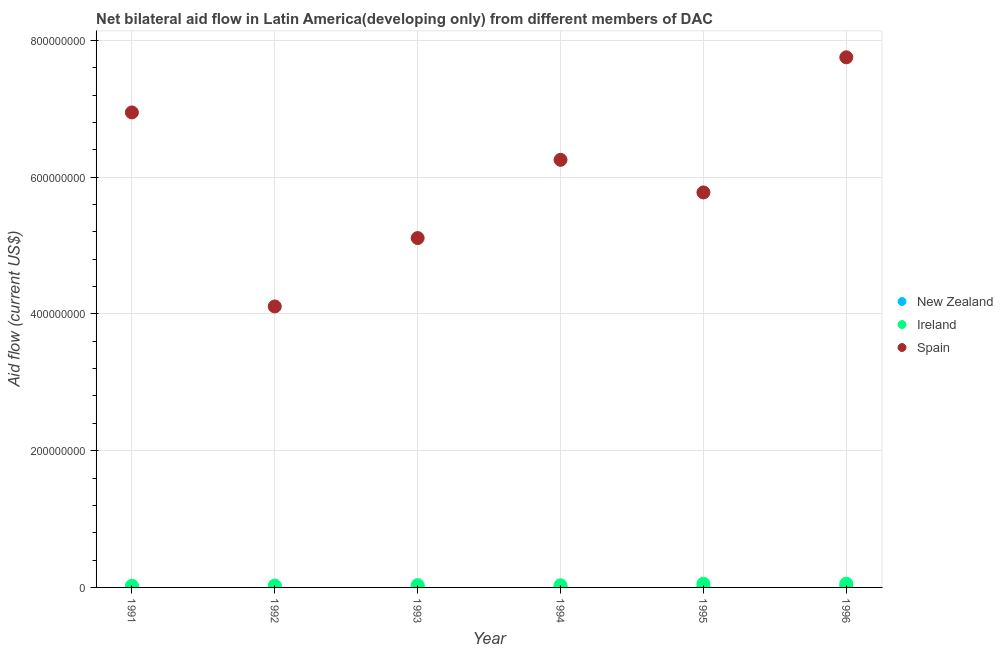Is the number of dotlines equal to the number of legend labels?
Make the answer very short. Yes. What is the amount of aid provided by ireland in 1992?
Provide a short and direct response. 2.78e+06. Across all years, what is the maximum amount of aid provided by ireland?
Your response must be concise. 5.49e+06. Across all years, what is the minimum amount of aid provided by spain?
Keep it short and to the point. 4.11e+08. In which year was the amount of aid provided by new zealand maximum?
Your response must be concise. 1995. In which year was the amount of aid provided by new zealand minimum?
Keep it short and to the point. 1992. What is the total amount of aid provided by spain in the graph?
Offer a very short reply. 3.59e+09. What is the difference between the amount of aid provided by ireland in 1995 and that in 1996?
Offer a very short reply. -1.10e+05. What is the difference between the amount of aid provided by new zealand in 1996 and the amount of aid provided by ireland in 1995?
Your answer should be compact. -4.50e+06. What is the average amount of aid provided by ireland per year?
Your response must be concise. 3.75e+06. In the year 1993, what is the difference between the amount of aid provided by ireland and amount of aid provided by new zealand?
Your answer should be compact. 2.87e+06. What is the ratio of the amount of aid provided by new zealand in 1995 to that in 1996?
Keep it short and to the point. 1.07. Is the amount of aid provided by new zealand in 1993 less than that in 1996?
Offer a very short reply. Yes. Is the difference between the amount of aid provided by spain in 1991 and 1996 greater than the difference between the amount of aid provided by new zealand in 1991 and 1996?
Offer a very short reply. No. What is the difference between the highest and the lowest amount of aid provided by new zealand?
Offer a terse response. 6.80e+05. Is the sum of the amount of aid provided by spain in 1993 and 1996 greater than the maximum amount of aid provided by ireland across all years?
Offer a very short reply. Yes. Is the amount of aid provided by spain strictly greater than the amount of aid provided by new zealand over the years?
Make the answer very short. Yes. How many dotlines are there?
Your answer should be compact. 3. How many years are there in the graph?
Your response must be concise. 6. What is the title of the graph?
Your answer should be very brief. Net bilateral aid flow in Latin America(developing only) from different members of DAC. Does "ICT services" appear as one of the legend labels in the graph?
Provide a short and direct response. No. What is the Aid flow (current US$) in New Zealand in 1991?
Keep it short and to the point. 2.90e+05. What is the Aid flow (current US$) in Ireland in 1991?
Ensure brevity in your answer.  2.41e+06. What is the Aid flow (current US$) of Spain in 1991?
Your response must be concise. 6.95e+08. What is the Aid flow (current US$) in New Zealand in 1992?
Provide a succinct answer. 2.60e+05. What is the Aid flow (current US$) of Ireland in 1992?
Your answer should be very brief. 2.78e+06. What is the Aid flow (current US$) of Spain in 1992?
Ensure brevity in your answer.  4.11e+08. What is the Aid flow (current US$) of New Zealand in 1993?
Your answer should be compact. 4.90e+05. What is the Aid flow (current US$) in Ireland in 1993?
Keep it short and to the point. 3.36e+06. What is the Aid flow (current US$) in Spain in 1993?
Ensure brevity in your answer.  5.11e+08. What is the Aid flow (current US$) in New Zealand in 1994?
Offer a very short reply. 5.90e+05. What is the Aid flow (current US$) of Ireland in 1994?
Offer a terse response. 3.08e+06. What is the Aid flow (current US$) of Spain in 1994?
Your answer should be compact. 6.25e+08. What is the Aid flow (current US$) of New Zealand in 1995?
Ensure brevity in your answer.  9.40e+05. What is the Aid flow (current US$) of Ireland in 1995?
Keep it short and to the point. 5.38e+06. What is the Aid flow (current US$) of Spain in 1995?
Provide a short and direct response. 5.78e+08. What is the Aid flow (current US$) in New Zealand in 1996?
Ensure brevity in your answer.  8.80e+05. What is the Aid flow (current US$) of Ireland in 1996?
Ensure brevity in your answer.  5.49e+06. What is the Aid flow (current US$) in Spain in 1996?
Make the answer very short. 7.75e+08. Across all years, what is the maximum Aid flow (current US$) of New Zealand?
Make the answer very short. 9.40e+05. Across all years, what is the maximum Aid flow (current US$) in Ireland?
Offer a terse response. 5.49e+06. Across all years, what is the maximum Aid flow (current US$) of Spain?
Your answer should be compact. 7.75e+08. Across all years, what is the minimum Aid flow (current US$) in New Zealand?
Give a very brief answer. 2.60e+05. Across all years, what is the minimum Aid flow (current US$) of Ireland?
Offer a very short reply. 2.41e+06. Across all years, what is the minimum Aid flow (current US$) in Spain?
Your answer should be compact. 4.11e+08. What is the total Aid flow (current US$) in New Zealand in the graph?
Offer a very short reply. 3.45e+06. What is the total Aid flow (current US$) of Ireland in the graph?
Ensure brevity in your answer.  2.25e+07. What is the total Aid flow (current US$) of Spain in the graph?
Make the answer very short. 3.59e+09. What is the difference between the Aid flow (current US$) of New Zealand in 1991 and that in 1992?
Keep it short and to the point. 3.00e+04. What is the difference between the Aid flow (current US$) of Ireland in 1991 and that in 1992?
Provide a short and direct response. -3.70e+05. What is the difference between the Aid flow (current US$) in Spain in 1991 and that in 1992?
Provide a short and direct response. 2.84e+08. What is the difference between the Aid flow (current US$) in New Zealand in 1991 and that in 1993?
Make the answer very short. -2.00e+05. What is the difference between the Aid flow (current US$) in Ireland in 1991 and that in 1993?
Provide a succinct answer. -9.50e+05. What is the difference between the Aid flow (current US$) in Spain in 1991 and that in 1993?
Offer a terse response. 1.84e+08. What is the difference between the Aid flow (current US$) in New Zealand in 1991 and that in 1994?
Make the answer very short. -3.00e+05. What is the difference between the Aid flow (current US$) of Ireland in 1991 and that in 1994?
Offer a terse response. -6.70e+05. What is the difference between the Aid flow (current US$) of Spain in 1991 and that in 1994?
Provide a short and direct response. 6.93e+07. What is the difference between the Aid flow (current US$) of New Zealand in 1991 and that in 1995?
Your answer should be very brief. -6.50e+05. What is the difference between the Aid flow (current US$) of Ireland in 1991 and that in 1995?
Ensure brevity in your answer.  -2.97e+06. What is the difference between the Aid flow (current US$) in Spain in 1991 and that in 1995?
Offer a very short reply. 1.17e+08. What is the difference between the Aid flow (current US$) in New Zealand in 1991 and that in 1996?
Provide a short and direct response. -5.90e+05. What is the difference between the Aid flow (current US$) in Ireland in 1991 and that in 1996?
Keep it short and to the point. -3.08e+06. What is the difference between the Aid flow (current US$) of Spain in 1991 and that in 1996?
Offer a very short reply. -8.06e+07. What is the difference between the Aid flow (current US$) of Ireland in 1992 and that in 1993?
Ensure brevity in your answer.  -5.80e+05. What is the difference between the Aid flow (current US$) in Spain in 1992 and that in 1993?
Offer a very short reply. -1.00e+08. What is the difference between the Aid flow (current US$) of New Zealand in 1992 and that in 1994?
Provide a succinct answer. -3.30e+05. What is the difference between the Aid flow (current US$) of Spain in 1992 and that in 1994?
Make the answer very short. -2.14e+08. What is the difference between the Aid flow (current US$) of New Zealand in 1992 and that in 1995?
Keep it short and to the point. -6.80e+05. What is the difference between the Aid flow (current US$) in Ireland in 1992 and that in 1995?
Your answer should be very brief. -2.60e+06. What is the difference between the Aid flow (current US$) of Spain in 1992 and that in 1995?
Keep it short and to the point. -1.67e+08. What is the difference between the Aid flow (current US$) in New Zealand in 1992 and that in 1996?
Your answer should be compact. -6.20e+05. What is the difference between the Aid flow (current US$) in Ireland in 1992 and that in 1996?
Keep it short and to the point. -2.71e+06. What is the difference between the Aid flow (current US$) of Spain in 1992 and that in 1996?
Provide a succinct answer. -3.64e+08. What is the difference between the Aid flow (current US$) of New Zealand in 1993 and that in 1994?
Your response must be concise. -1.00e+05. What is the difference between the Aid flow (current US$) in Spain in 1993 and that in 1994?
Your answer should be compact. -1.14e+08. What is the difference between the Aid flow (current US$) of New Zealand in 1993 and that in 1995?
Provide a short and direct response. -4.50e+05. What is the difference between the Aid flow (current US$) in Ireland in 1993 and that in 1995?
Your response must be concise. -2.02e+06. What is the difference between the Aid flow (current US$) in Spain in 1993 and that in 1995?
Your answer should be very brief. -6.67e+07. What is the difference between the Aid flow (current US$) of New Zealand in 1993 and that in 1996?
Your answer should be very brief. -3.90e+05. What is the difference between the Aid flow (current US$) of Ireland in 1993 and that in 1996?
Offer a terse response. -2.13e+06. What is the difference between the Aid flow (current US$) of Spain in 1993 and that in 1996?
Provide a succinct answer. -2.64e+08. What is the difference between the Aid flow (current US$) of New Zealand in 1994 and that in 1995?
Your response must be concise. -3.50e+05. What is the difference between the Aid flow (current US$) in Ireland in 1994 and that in 1995?
Provide a succinct answer. -2.30e+06. What is the difference between the Aid flow (current US$) of Spain in 1994 and that in 1995?
Your response must be concise. 4.77e+07. What is the difference between the Aid flow (current US$) of New Zealand in 1994 and that in 1996?
Your answer should be very brief. -2.90e+05. What is the difference between the Aid flow (current US$) in Ireland in 1994 and that in 1996?
Your answer should be compact. -2.41e+06. What is the difference between the Aid flow (current US$) in Spain in 1994 and that in 1996?
Your answer should be very brief. -1.50e+08. What is the difference between the Aid flow (current US$) in Ireland in 1995 and that in 1996?
Provide a succinct answer. -1.10e+05. What is the difference between the Aid flow (current US$) of Spain in 1995 and that in 1996?
Offer a very short reply. -1.98e+08. What is the difference between the Aid flow (current US$) of New Zealand in 1991 and the Aid flow (current US$) of Ireland in 1992?
Make the answer very short. -2.49e+06. What is the difference between the Aid flow (current US$) in New Zealand in 1991 and the Aid flow (current US$) in Spain in 1992?
Give a very brief answer. -4.11e+08. What is the difference between the Aid flow (current US$) of Ireland in 1991 and the Aid flow (current US$) of Spain in 1992?
Your response must be concise. -4.08e+08. What is the difference between the Aid flow (current US$) in New Zealand in 1991 and the Aid flow (current US$) in Ireland in 1993?
Provide a short and direct response. -3.07e+06. What is the difference between the Aid flow (current US$) in New Zealand in 1991 and the Aid flow (current US$) in Spain in 1993?
Ensure brevity in your answer.  -5.11e+08. What is the difference between the Aid flow (current US$) in Ireland in 1991 and the Aid flow (current US$) in Spain in 1993?
Offer a terse response. -5.09e+08. What is the difference between the Aid flow (current US$) in New Zealand in 1991 and the Aid flow (current US$) in Ireland in 1994?
Keep it short and to the point. -2.79e+06. What is the difference between the Aid flow (current US$) in New Zealand in 1991 and the Aid flow (current US$) in Spain in 1994?
Keep it short and to the point. -6.25e+08. What is the difference between the Aid flow (current US$) of Ireland in 1991 and the Aid flow (current US$) of Spain in 1994?
Ensure brevity in your answer.  -6.23e+08. What is the difference between the Aid flow (current US$) of New Zealand in 1991 and the Aid flow (current US$) of Ireland in 1995?
Provide a short and direct response. -5.09e+06. What is the difference between the Aid flow (current US$) in New Zealand in 1991 and the Aid flow (current US$) in Spain in 1995?
Offer a terse response. -5.77e+08. What is the difference between the Aid flow (current US$) of Ireland in 1991 and the Aid flow (current US$) of Spain in 1995?
Provide a short and direct response. -5.75e+08. What is the difference between the Aid flow (current US$) in New Zealand in 1991 and the Aid flow (current US$) in Ireland in 1996?
Your response must be concise. -5.20e+06. What is the difference between the Aid flow (current US$) of New Zealand in 1991 and the Aid flow (current US$) of Spain in 1996?
Provide a succinct answer. -7.75e+08. What is the difference between the Aid flow (current US$) in Ireland in 1991 and the Aid flow (current US$) in Spain in 1996?
Give a very brief answer. -7.73e+08. What is the difference between the Aid flow (current US$) of New Zealand in 1992 and the Aid flow (current US$) of Ireland in 1993?
Offer a terse response. -3.10e+06. What is the difference between the Aid flow (current US$) of New Zealand in 1992 and the Aid flow (current US$) of Spain in 1993?
Your response must be concise. -5.11e+08. What is the difference between the Aid flow (current US$) in Ireland in 1992 and the Aid flow (current US$) in Spain in 1993?
Your response must be concise. -5.08e+08. What is the difference between the Aid flow (current US$) in New Zealand in 1992 and the Aid flow (current US$) in Ireland in 1994?
Offer a terse response. -2.82e+06. What is the difference between the Aid flow (current US$) of New Zealand in 1992 and the Aid flow (current US$) of Spain in 1994?
Provide a short and direct response. -6.25e+08. What is the difference between the Aid flow (current US$) of Ireland in 1992 and the Aid flow (current US$) of Spain in 1994?
Your response must be concise. -6.23e+08. What is the difference between the Aid flow (current US$) of New Zealand in 1992 and the Aid flow (current US$) of Ireland in 1995?
Make the answer very short. -5.12e+06. What is the difference between the Aid flow (current US$) of New Zealand in 1992 and the Aid flow (current US$) of Spain in 1995?
Your response must be concise. -5.77e+08. What is the difference between the Aid flow (current US$) in Ireland in 1992 and the Aid flow (current US$) in Spain in 1995?
Ensure brevity in your answer.  -5.75e+08. What is the difference between the Aid flow (current US$) of New Zealand in 1992 and the Aid flow (current US$) of Ireland in 1996?
Give a very brief answer. -5.23e+06. What is the difference between the Aid flow (current US$) of New Zealand in 1992 and the Aid flow (current US$) of Spain in 1996?
Your answer should be very brief. -7.75e+08. What is the difference between the Aid flow (current US$) of Ireland in 1992 and the Aid flow (current US$) of Spain in 1996?
Offer a terse response. -7.72e+08. What is the difference between the Aid flow (current US$) of New Zealand in 1993 and the Aid flow (current US$) of Ireland in 1994?
Provide a short and direct response. -2.59e+06. What is the difference between the Aid flow (current US$) in New Zealand in 1993 and the Aid flow (current US$) in Spain in 1994?
Ensure brevity in your answer.  -6.25e+08. What is the difference between the Aid flow (current US$) of Ireland in 1993 and the Aid flow (current US$) of Spain in 1994?
Offer a very short reply. -6.22e+08. What is the difference between the Aid flow (current US$) of New Zealand in 1993 and the Aid flow (current US$) of Ireland in 1995?
Provide a succinct answer. -4.89e+06. What is the difference between the Aid flow (current US$) in New Zealand in 1993 and the Aid flow (current US$) in Spain in 1995?
Offer a terse response. -5.77e+08. What is the difference between the Aid flow (current US$) of Ireland in 1993 and the Aid flow (current US$) of Spain in 1995?
Keep it short and to the point. -5.74e+08. What is the difference between the Aid flow (current US$) in New Zealand in 1993 and the Aid flow (current US$) in Ireland in 1996?
Your answer should be compact. -5.00e+06. What is the difference between the Aid flow (current US$) of New Zealand in 1993 and the Aid flow (current US$) of Spain in 1996?
Your response must be concise. -7.75e+08. What is the difference between the Aid flow (current US$) of Ireland in 1993 and the Aid flow (current US$) of Spain in 1996?
Give a very brief answer. -7.72e+08. What is the difference between the Aid flow (current US$) of New Zealand in 1994 and the Aid flow (current US$) of Ireland in 1995?
Ensure brevity in your answer.  -4.79e+06. What is the difference between the Aid flow (current US$) of New Zealand in 1994 and the Aid flow (current US$) of Spain in 1995?
Provide a short and direct response. -5.77e+08. What is the difference between the Aid flow (current US$) of Ireland in 1994 and the Aid flow (current US$) of Spain in 1995?
Your answer should be very brief. -5.75e+08. What is the difference between the Aid flow (current US$) of New Zealand in 1994 and the Aid flow (current US$) of Ireland in 1996?
Your answer should be very brief. -4.90e+06. What is the difference between the Aid flow (current US$) of New Zealand in 1994 and the Aid flow (current US$) of Spain in 1996?
Offer a very short reply. -7.75e+08. What is the difference between the Aid flow (current US$) of Ireland in 1994 and the Aid flow (current US$) of Spain in 1996?
Your response must be concise. -7.72e+08. What is the difference between the Aid flow (current US$) of New Zealand in 1995 and the Aid flow (current US$) of Ireland in 1996?
Offer a terse response. -4.55e+06. What is the difference between the Aid flow (current US$) of New Zealand in 1995 and the Aid flow (current US$) of Spain in 1996?
Keep it short and to the point. -7.74e+08. What is the difference between the Aid flow (current US$) of Ireland in 1995 and the Aid flow (current US$) of Spain in 1996?
Ensure brevity in your answer.  -7.70e+08. What is the average Aid flow (current US$) of New Zealand per year?
Offer a very short reply. 5.75e+05. What is the average Aid flow (current US$) in Ireland per year?
Keep it short and to the point. 3.75e+06. What is the average Aid flow (current US$) of Spain per year?
Make the answer very short. 5.99e+08. In the year 1991, what is the difference between the Aid flow (current US$) of New Zealand and Aid flow (current US$) of Ireland?
Your answer should be compact. -2.12e+06. In the year 1991, what is the difference between the Aid flow (current US$) of New Zealand and Aid flow (current US$) of Spain?
Keep it short and to the point. -6.94e+08. In the year 1991, what is the difference between the Aid flow (current US$) of Ireland and Aid flow (current US$) of Spain?
Your answer should be very brief. -6.92e+08. In the year 1992, what is the difference between the Aid flow (current US$) of New Zealand and Aid flow (current US$) of Ireland?
Provide a succinct answer. -2.52e+06. In the year 1992, what is the difference between the Aid flow (current US$) in New Zealand and Aid flow (current US$) in Spain?
Offer a very short reply. -4.11e+08. In the year 1992, what is the difference between the Aid flow (current US$) in Ireland and Aid flow (current US$) in Spain?
Provide a short and direct response. -4.08e+08. In the year 1993, what is the difference between the Aid flow (current US$) of New Zealand and Aid flow (current US$) of Ireland?
Ensure brevity in your answer.  -2.87e+06. In the year 1993, what is the difference between the Aid flow (current US$) in New Zealand and Aid flow (current US$) in Spain?
Keep it short and to the point. -5.10e+08. In the year 1993, what is the difference between the Aid flow (current US$) in Ireland and Aid flow (current US$) in Spain?
Your answer should be very brief. -5.08e+08. In the year 1994, what is the difference between the Aid flow (current US$) of New Zealand and Aid flow (current US$) of Ireland?
Your response must be concise. -2.49e+06. In the year 1994, what is the difference between the Aid flow (current US$) in New Zealand and Aid flow (current US$) in Spain?
Your response must be concise. -6.25e+08. In the year 1994, what is the difference between the Aid flow (current US$) of Ireland and Aid flow (current US$) of Spain?
Offer a very short reply. -6.22e+08. In the year 1995, what is the difference between the Aid flow (current US$) of New Zealand and Aid flow (current US$) of Ireland?
Provide a succinct answer. -4.44e+06. In the year 1995, what is the difference between the Aid flow (current US$) of New Zealand and Aid flow (current US$) of Spain?
Your answer should be very brief. -5.77e+08. In the year 1995, what is the difference between the Aid flow (current US$) in Ireland and Aid flow (current US$) in Spain?
Offer a very short reply. -5.72e+08. In the year 1996, what is the difference between the Aid flow (current US$) of New Zealand and Aid flow (current US$) of Ireland?
Provide a succinct answer. -4.61e+06. In the year 1996, what is the difference between the Aid flow (current US$) in New Zealand and Aid flow (current US$) in Spain?
Ensure brevity in your answer.  -7.74e+08. In the year 1996, what is the difference between the Aid flow (current US$) in Ireland and Aid flow (current US$) in Spain?
Your response must be concise. -7.70e+08. What is the ratio of the Aid flow (current US$) of New Zealand in 1991 to that in 1992?
Your answer should be compact. 1.12. What is the ratio of the Aid flow (current US$) in Ireland in 1991 to that in 1992?
Keep it short and to the point. 0.87. What is the ratio of the Aid flow (current US$) in Spain in 1991 to that in 1992?
Your answer should be very brief. 1.69. What is the ratio of the Aid flow (current US$) in New Zealand in 1991 to that in 1993?
Give a very brief answer. 0.59. What is the ratio of the Aid flow (current US$) of Ireland in 1991 to that in 1993?
Your answer should be compact. 0.72. What is the ratio of the Aid flow (current US$) in Spain in 1991 to that in 1993?
Your answer should be compact. 1.36. What is the ratio of the Aid flow (current US$) in New Zealand in 1991 to that in 1994?
Keep it short and to the point. 0.49. What is the ratio of the Aid flow (current US$) in Ireland in 1991 to that in 1994?
Provide a succinct answer. 0.78. What is the ratio of the Aid flow (current US$) of Spain in 1991 to that in 1994?
Offer a very short reply. 1.11. What is the ratio of the Aid flow (current US$) of New Zealand in 1991 to that in 1995?
Keep it short and to the point. 0.31. What is the ratio of the Aid flow (current US$) of Ireland in 1991 to that in 1995?
Ensure brevity in your answer.  0.45. What is the ratio of the Aid flow (current US$) in Spain in 1991 to that in 1995?
Your answer should be compact. 1.2. What is the ratio of the Aid flow (current US$) of New Zealand in 1991 to that in 1996?
Provide a short and direct response. 0.33. What is the ratio of the Aid flow (current US$) of Ireland in 1991 to that in 1996?
Give a very brief answer. 0.44. What is the ratio of the Aid flow (current US$) in Spain in 1991 to that in 1996?
Your answer should be compact. 0.9. What is the ratio of the Aid flow (current US$) of New Zealand in 1992 to that in 1993?
Your answer should be very brief. 0.53. What is the ratio of the Aid flow (current US$) in Ireland in 1992 to that in 1993?
Give a very brief answer. 0.83. What is the ratio of the Aid flow (current US$) of Spain in 1992 to that in 1993?
Keep it short and to the point. 0.8. What is the ratio of the Aid flow (current US$) in New Zealand in 1992 to that in 1994?
Give a very brief answer. 0.44. What is the ratio of the Aid flow (current US$) in Ireland in 1992 to that in 1994?
Your answer should be very brief. 0.9. What is the ratio of the Aid flow (current US$) in Spain in 1992 to that in 1994?
Give a very brief answer. 0.66. What is the ratio of the Aid flow (current US$) of New Zealand in 1992 to that in 1995?
Your response must be concise. 0.28. What is the ratio of the Aid flow (current US$) of Ireland in 1992 to that in 1995?
Keep it short and to the point. 0.52. What is the ratio of the Aid flow (current US$) in Spain in 1992 to that in 1995?
Ensure brevity in your answer.  0.71. What is the ratio of the Aid flow (current US$) in New Zealand in 1992 to that in 1996?
Make the answer very short. 0.3. What is the ratio of the Aid flow (current US$) of Ireland in 1992 to that in 1996?
Your answer should be very brief. 0.51. What is the ratio of the Aid flow (current US$) in Spain in 1992 to that in 1996?
Offer a very short reply. 0.53. What is the ratio of the Aid flow (current US$) in New Zealand in 1993 to that in 1994?
Your response must be concise. 0.83. What is the ratio of the Aid flow (current US$) of Ireland in 1993 to that in 1994?
Keep it short and to the point. 1.09. What is the ratio of the Aid flow (current US$) of Spain in 1993 to that in 1994?
Your answer should be compact. 0.82. What is the ratio of the Aid flow (current US$) of New Zealand in 1993 to that in 1995?
Offer a terse response. 0.52. What is the ratio of the Aid flow (current US$) in Ireland in 1993 to that in 1995?
Your response must be concise. 0.62. What is the ratio of the Aid flow (current US$) of Spain in 1993 to that in 1995?
Your answer should be compact. 0.88. What is the ratio of the Aid flow (current US$) in New Zealand in 1993 to that in 1996?
Make the answer very short. 0.56. What is the ratio of the Aid flow (current US$) of Ireland in 1993 to that in 1996?
Make the answer very short. 0.61. What is the ratio of the Aid flow (current US$) in Spain in 1993 to that in 1996?
Your answer should be compact. 0.66. What is the ratio of the Aid flow (current US$) in New Zealand in 1994 to that in 1995?
Provide a short and direct response. 0.63. What is the ratio of the Aid flow (current US$) of Ireland in 1994 to that in 1995?
Your response must be concise. 0.57. What is the ratio of the Aid flow (current US$) in Spain in 1994 to that in 1995?
Provide a short and direct response. 1.08. What is the ratio of the Aid flow (current US$) of New Zealand in 1994 to that in 1996?
Your answer should be compact. 0.67. What is the ratio of the Aid flow (current US$) of Ireland in 1994 to that in 1996?
Offer a terse response. 0.56. What is the ratio of the Aid flow (current US$) in Spain in 1994 to that in 1996?
Ensure brevity in your answer.  0.81. What is the ratio of the Aid flow (current US$) in New Zealand in 1995 to that in 1996?
Ensure brevity in your answer.  1.07. What is the ratio of the Aid flow (current US$) of Ireland in 1995 to that in 1996?
Offer a terse response. 0.98. What is the ratio of the Aid flow (current US$) in Spain in 1995 to that in 1996?
Provide a succinct answer. 0.75. What is the difference between the highest and the second highest Aid flow (current US$) of New Zealand?
Your answer should be very brief. 6.00e+04. What is the difference between the highest and the second highest Aid flow (current US$) of Spain?
Ensure brevity in your answer.  8.06e+07. What is the difference between the highest and the lowest Aid flow (current US$) of New Zealand?
Your response must be concise. 6.80e+05. What is the difference between the highest and the lowest Aid flow (current US$) in Ireland?
Provide a succinct answer. 3.08e+06. What is the difference between the highest and the lowest Aid flow (current US$) of Spain?
Keep it short and to the point. 3.64e+08. 